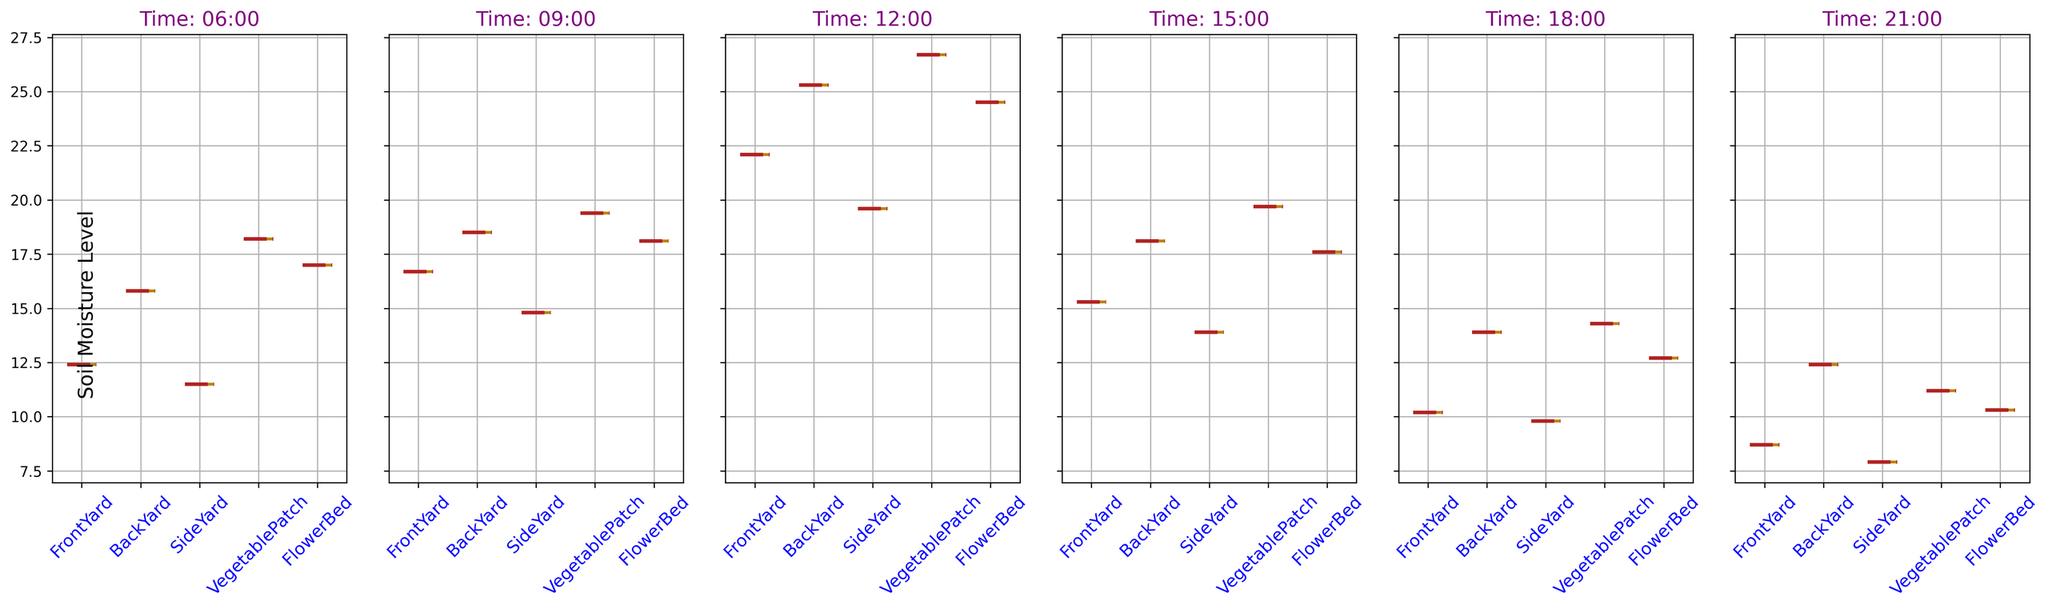Which garden location has the highest soil moisture level at 6:00 AM? To find the garden location with the highest soil moisture level at 6:00 AM, we look at the data points on the box plot for each location at this time. The highest value observed is for the VegetablePatch.
Answer: VegetablePatch Which time of the day shows the lowest median soil moisture level for the FrontYard? Median is indicated by a line inside the box in a box plot. By comparing the medians of the FrontYard box plots across all times, the lowest median value is observed at 21:00.
Answer: 21:00 Compare the range of soil moisture levels in the VegetablePatch at 12:00 and 15:00. Which one is larger? The range of soil moisture levels is given by the difference between the maximum and minimum values. By visually comparing the length of the boxes (from the bottom whisker to the top whisker), the range at 12:00 is larger than at 15:00.
Answer: 12:00 Which garden location experienced the most significant drop in soil moisture from 12:00 to 18:00? To determine this, we look at the difference in soil moisture levels between 12:00 and 18:00 for each location. The largest decrease in soil moisture is observed in the FrontYard.
Answer: FrontYard At what time does the FlowerBed have the lowest variance in soil moisture levels? Variance can be inferred from the spread of the box plot. The narrower the box and whiskers, the lower the variance. For FlowerBed, the plot at 21:00 shows the smallest spread, indicating the lowest variance.
Answer: 21:00 Is the soil moisture level at SideYard at 9:00 greater than or less than that at 15:00? Compare the median lines in the box plots for SideYard at 9:00 and 15:00. The median at 9:00 is higher than at 15:00, indicating greater soil moisture at 9:00.
Answer: Greater Which garden location has the most consistent soil moisture levels throughout the day? Consistency is indicated by the smallest variation in box plot sizes across different times. Examining all the locations, the FlowerBed appears to have the most consistent soil moisture levels throughout the day.
Answer: FlowerBed What is the general trend in soil moisture levels as the day progresses for the VegetablePatch? Observing the box plots for the VegetablePatch from 06:00 to 21:00, the general trend shows an increase in soil moisture levels towards noon and then a decline until 21:00.
Answer: Increase then decrease During which time interval does the BackYard show the steepest drop in soil moisture levels? Look at the medians or the total spread of the box plots for the BackYard. The steepest drop in soil moisture occurs between 12:00 and 18:00.
Answer: 12:00 to 18:00 